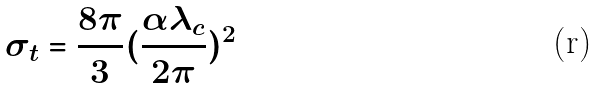<formula> <loc_0><loc_0><loc_500><loc_500>\sigma _ { t } = \frac { 8 \pi } { 3 } ( \frac { \alpha \lambda _ { c } } { 2 \pi } ) ^ { 2 }</formula> 